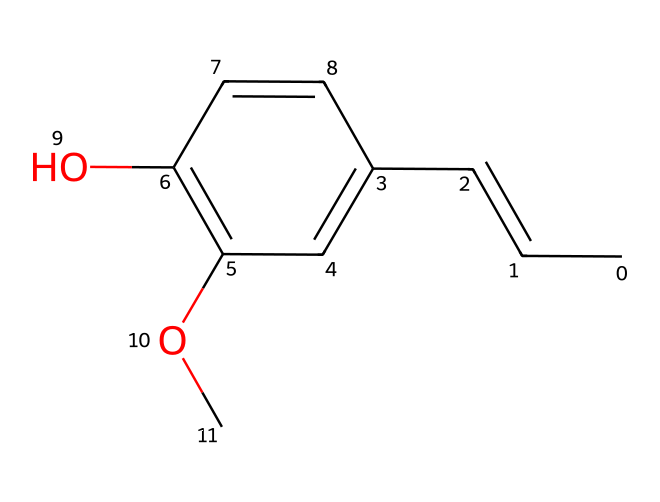What is the molecular formula for eugenol? To find the molecular formula, we can count the number of each type of atom from the SMILES representation. The molecule has 10 carbon (C) atoms, 12 hydrogen (H) atoms, and 2 oxygen (O) atoms. Thus, the molecular formula is C10H12O2.
Answer: C10H12O2 How many rings are present in the structure of eugenol? The chemical structure shows one cyclic component, which is the benzene ring in the molecule. Therefore, the total number of rings is one.
Answer: 1 What functional groups can be identified in eugenol? In the structure, we can identify two functional groups: a phenolic hydroxyl group (-OH) and an ether group (-O-). Thus, there are two functional groups present.
Answer: two How many double bonds are in the eugenol structure? By analyzing the SMILES representation, we see that there are two double bonds in the structure. One is in the alkene portion (CC=CC) and the other is part of the benzene ring structure. Thus, the total count is two.
Answer: 2 Which atom is bonded to the hydroxyl group in eugenol? The hydroxyl group (-OH) is attached to a carbon atom in the benzene ring (specifically, carbon 1 on the aromatic ring). Thus, the atom bonded to the hydroxyl group is carbon.
Answer: carbon Is eugenol a saturated or unsaturated compound? Eugenol contains both single and double bonds, indicating that it has an unsaturated character. The presence of double bonds classifies it as unsaturated. Therefore, eugenol is unsaturated.
Answer: unsaturated 